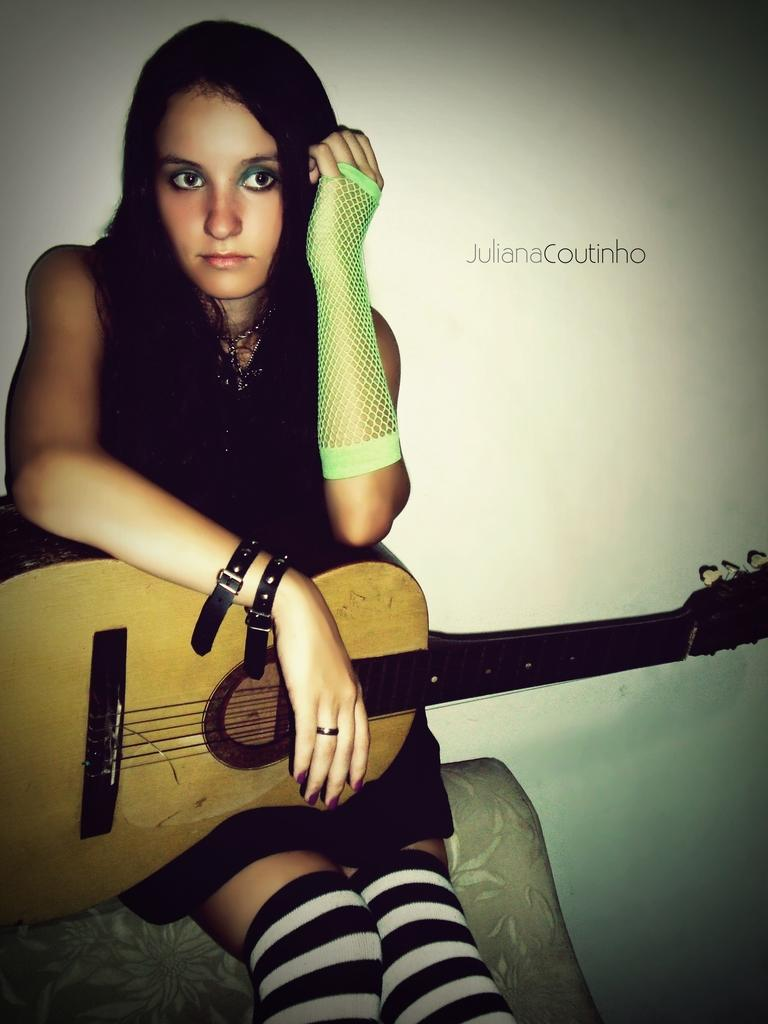What is the main subject of the image? The main subject of the image is a woman. What is the woman holding in the image? The woman is holding a guitar. What type of harmony can be heard in the image? There is no sound or music present in the image, so it is not possible to determine what type of harmony might be heard. 